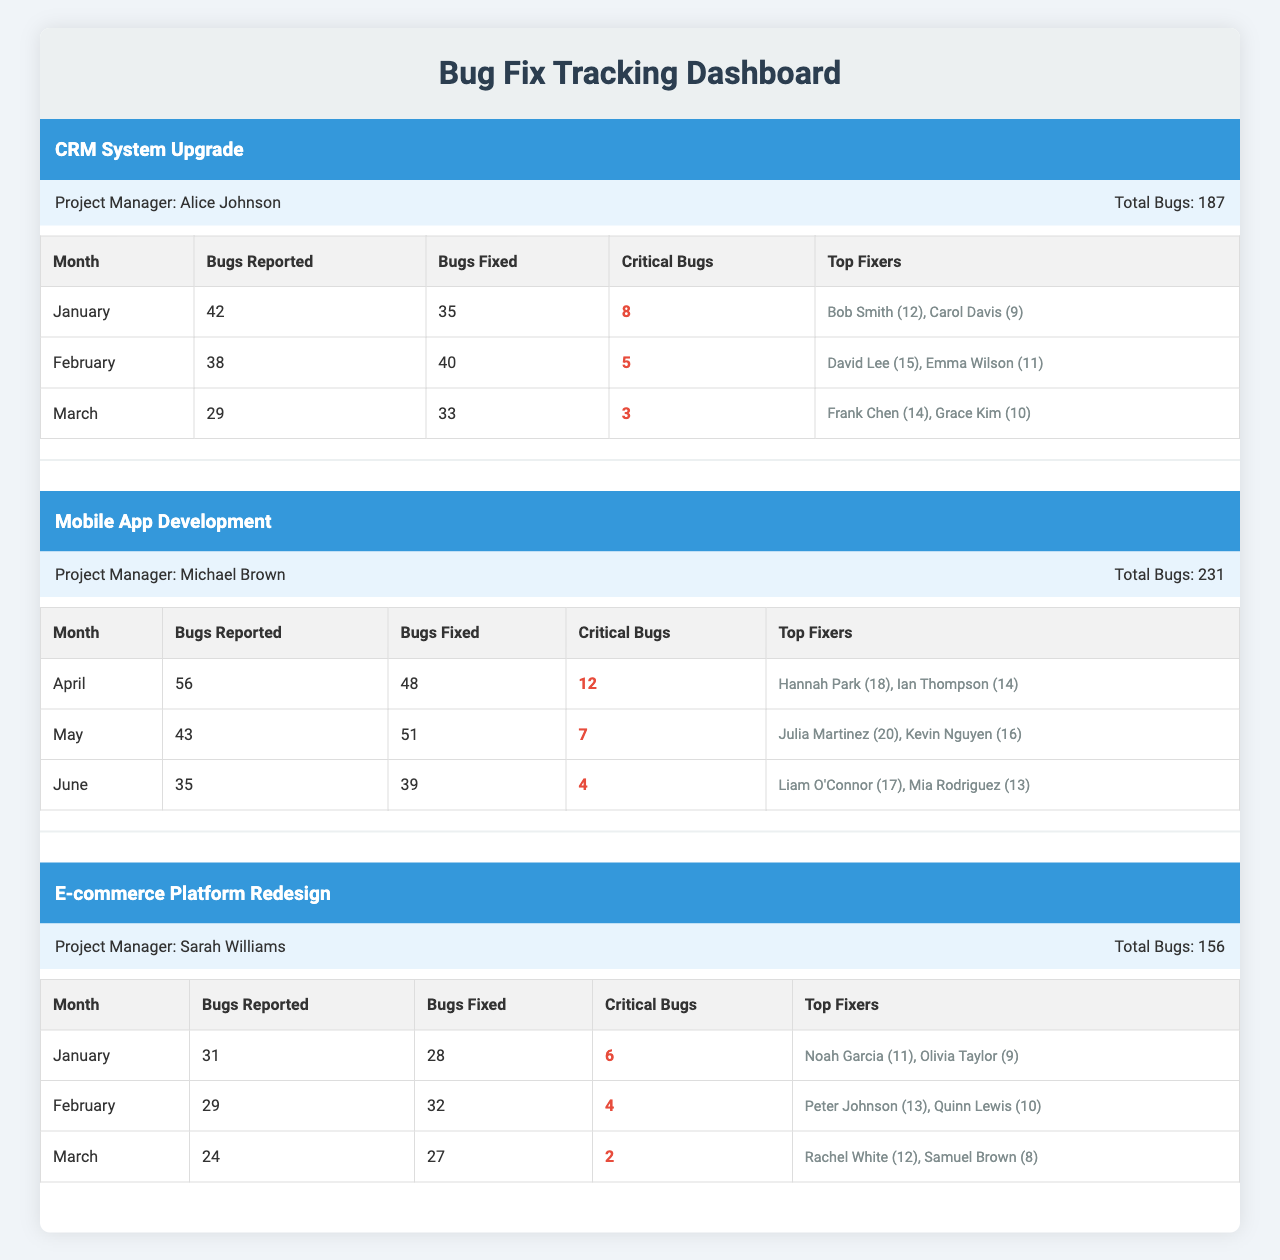What is the total number of bugs reported in the CRM System Upgrade project during the first three months? To find the total number of bugs reported, we need to add the bugs reported each month: January (42) + February (38) + March (29) = 109.
Answer: 109 Which project had the highest number of bugs fixed in May? The Mobile App Development project had 51 bugs fixed in May, which is the only project that reported fixing bugs in that month.
Answer: 51 How many critical bugs were reported in the Mobile App Development project over the three months? The critical bugs reported during the three months in Mobile App Development were: April (12) + May (7) + June (4) = 23 critical bugs.
Answer: 23 Who was the top fixer in the CRM System Upgrade project for February? The top fixer for February in the CRM System Upgrade project was David Lee, who fixed 15 bugs.
Answer: David Lee What is the average number of bugs fixed per month for the E-commerce Platform Redesign project? To calculate the average, sum the bugs fixed over the three months: January (28) + February (32) + March (27) = 87. Divide by the number of months (3): 87/3 = 29.
Answer: 29 Did the Mobile App Development project have more bugs reported in April than in June? Yes, in April, 56 bugs were reported, whereas in June, 35 bugs were reported.
Answer: Yes What is the total number of bugs fixed in the CRM System Upgrade project in March? In March, the CRM System Upgrade project had 33 bugs fixed.
Answer: 33 Which project had the least number of critical bugs in February? The project with the least critical bugs in February was the E-commerce Platform Redesign, with 4 critical bugs reported, compared to 5 in CRM System Upgrade and 7 in Mobile App Development.
Answer: E-commerce Platform Redesign How many total bugs were reported across all projects in January? In January, the total bugs reported were: CRM System Upgrade (42) + E-commerce Platform Redesign (31) = 73. The Mobile App Development did not report bugs for that month, totaling 73.
Answer: 73 Which bug fixer fixed the most bugs in April for the Mobile App Development project? The top fixer in April was Hannah Park, who fixed 18 bugs, more than Ian Thompson, who fixed 14 bugs.
Answer: Hannah Park 